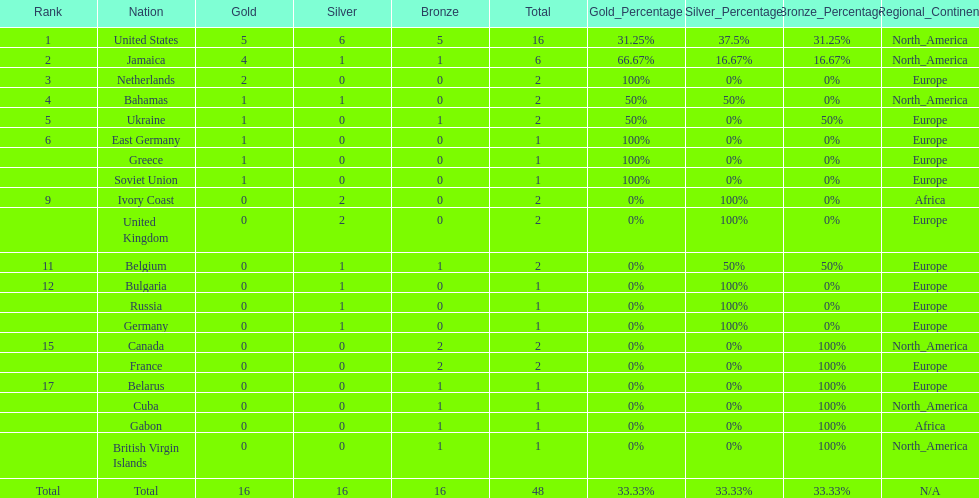After the united states, what country won the most gold medals. Jamaica. Could you parse the entire table? {'header': ['Rank', 'Nation', 'Gold', 'Silver', 'Bronze', 'Total', 'Gold_Percentage', 'Silver_Percentage', 'Bronze_Percentage', 'Regional_Continent'], 'rows': [['1', 'United States', '5', '6', '5', '16', '31.25%', '37.5%', '31.25%', 'North_America'], ['2', 'Jamaica', '4', '1', '1', '6', '66.67%', '16.67%', '16.67%', 'North_America'], ['3', 'Netherlands', '2', '0', '0', '2', '100%', '0%', '0%', 'Europe'], ['4', 'Bahamas', '1', '1', '0', '2', '50%', '50%', '0%', 'North_America'], ['5', 'Ukraine', '1', '0', '1', '2', '50%', '0%', '50%', 'Europe'], ['6', 'East Germany', '1', '0', '0', '1', '100%', '0%', '0%', 'Europe'], ['', 'Greece', '1', '0', '0', '1', '100%', '0%', '0%', 'Europe'], ['', 'Soviet Union', '1', '0', '0', '1', '100%', '0%', '0%', 'Europe'], ['9', 'Ivory Coast', '0', '2', '0', '2', '0%', '100%', '0%', 'Africa'], ['', 'United Kingdom', '0', '2', '0', '2', '0%', '100%', '0%', 'Europe'], ['11', 'Belgium', '0', '1', '1', '2', '0%', '50%', '50%', 'Europe'], ['12', 'Bulgaria', '0', '1', '0', '1', '0%', '100%', '0%', 'Europe'], ['', 'Russia', '0', '1', '0', '1', '0%', '100%', '0%', 'Europe'], ['', 'Germany', '0', '1', '0', '1', '0%', '100%', '0%', 'Europe'], ['15', 'Canada', '0', '0', '2', '2', '0%', '0%', '100%', 'North_America'], ['', 'France', '0', '0', '2', '2', '0%', '0%', '100%', 'Europe'], ['17', 'Belarus', '0', '0', '1', '1', '0%', '0%', '100%', 'Europe'], ['', 'Cuba', '0', '0', '1', '1', '0%', '0%', '100%', 'North_America'], ['', 'Gabon', '0', '0', '1', '1', '0%', '0%', '100%', 'Africa'], ['', 'British Virgin Islands', '0', '0', '1', '1', '0%', '0%', '100%', 'North_America'], ['Total', 'Total', '16', '16', '16', '48', '33.33%', '33.33%', '33.33%', 'N/A']]} 